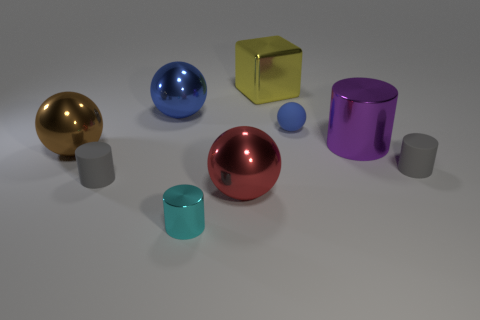Add 1 green shiny spheres. How many objects exist? 10 Subtract all blocks. How many objects are left? 8 Subtract 0 yellow cylinders. How many objects are left? 9 Subtract all small gray objects. Subtract all cyan objects. How many objects are left? 6 Add 1 large yellow metal cubes. How many large yellow metal cubes are left? 2 Add 4 tiny gray things. How many tiny gray things exist? 6 